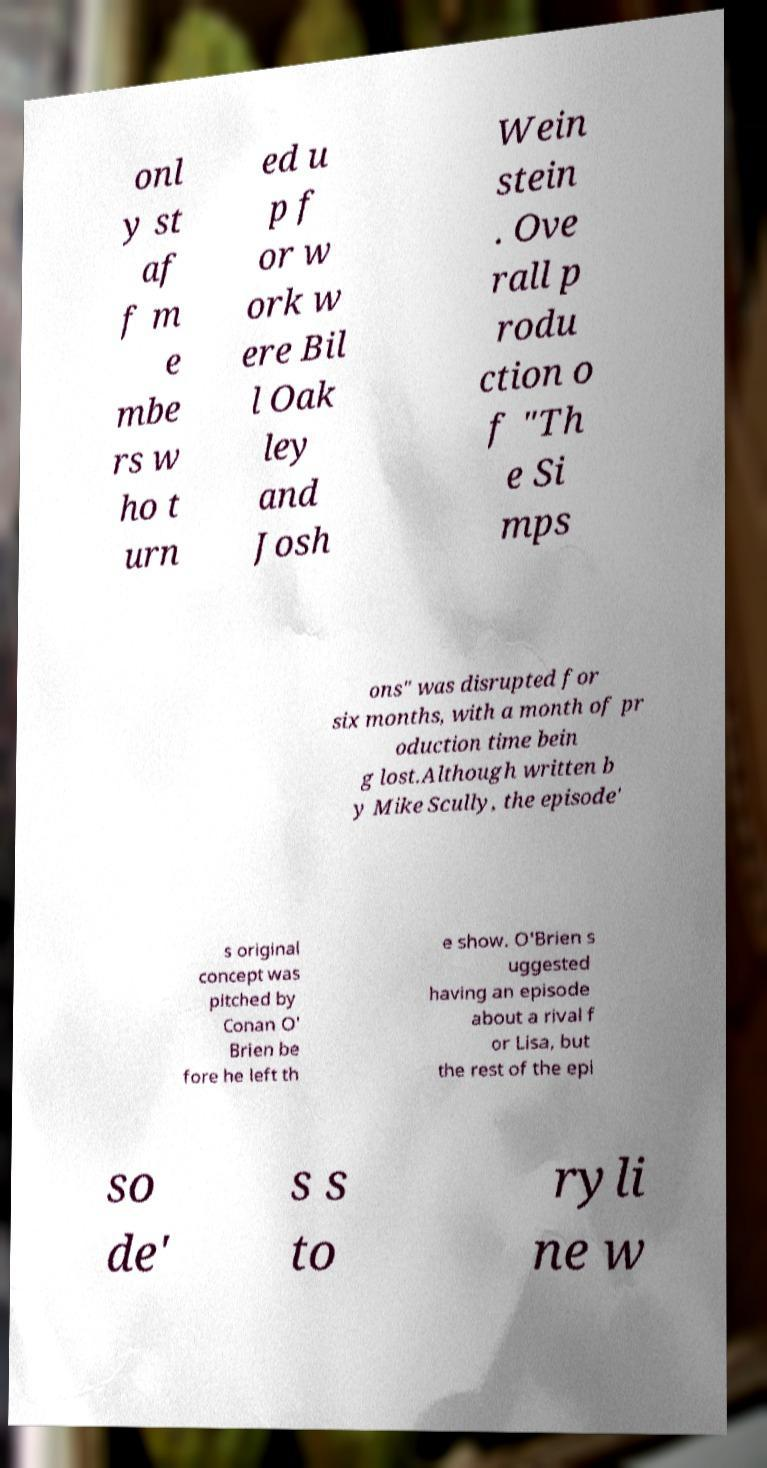Could you assist in decoding the text presented in this image and type it out clearly? onl y st af f m e mbe rs w ho t urn ed u p f or w ork w ere Bil l Oak ley and Josh Wein stein . Ove rall p rodu ction o f "Th e Si mps ons" was disrupted for six months, with a month of pr oduction time bein g lost.Although written b y Mike Scully, the episode' s original concept was pitched by Conan O' Brien be fore he left th e show. O'Brien s uggested having an episode about a rival f or Lisa, but the rest of the epi so de' s s to ryli ne w 